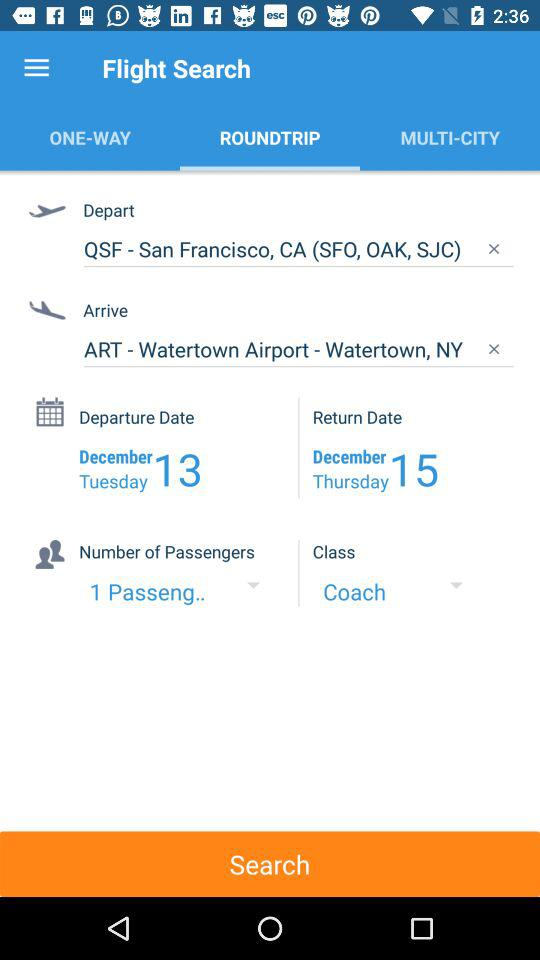How many passengers are there?
Answer the question using a single word or phrase. 1 